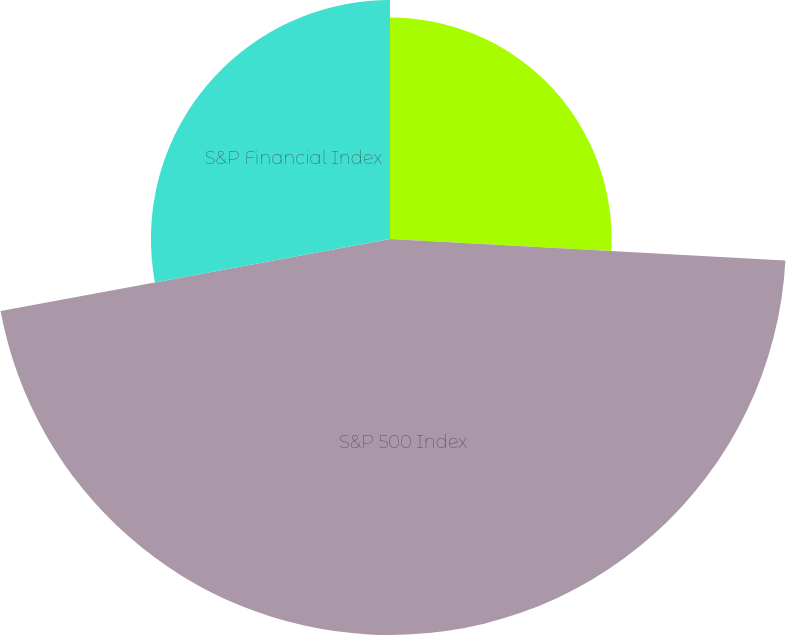Convert chart to OTSL. <chart><loc_0><loc_0><loc_500><loc_500><pie_chart><fcel>State Street Corporation<fcel>S&P 500 Index<fcel>S&P Financial Index<nl><fcel>25.87%<fcel>46.23%<fcel>27.91%<nl></chart> 